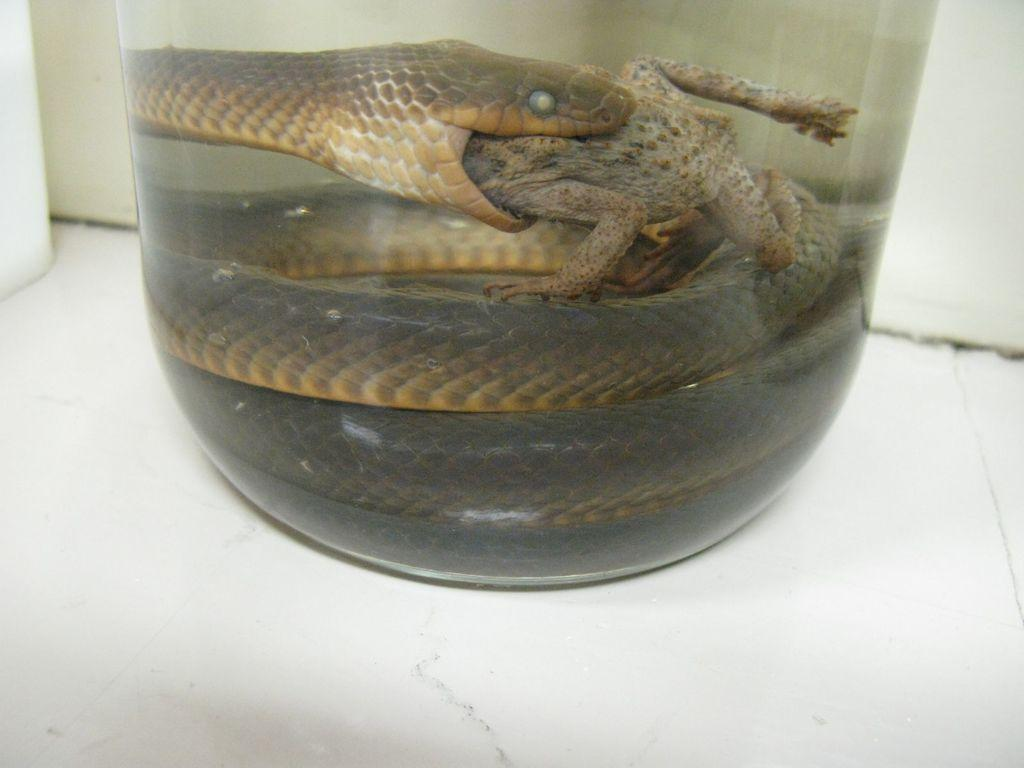What animal can be seen in the image? There is a snake in the image. What is the snake doing in the image? The snake is eating a frog in the image. Where are the snake and frog located? They are in a glass bottle in the image. Where is the glass bottle situated? The glass bottle is on the floor in the image. What type of bead is used as a decoration in the image? There is no bead present in the image. What type of place is depicted in the image? The image does not depict a specific place; it focuses on the snake and frog in a glass bottle. 